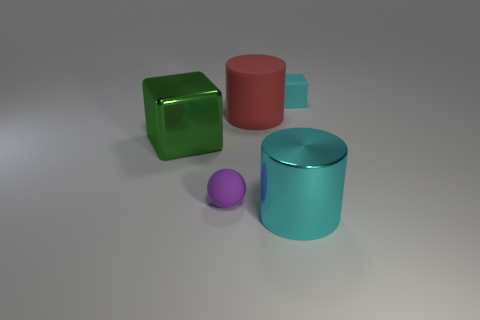What is the large red object made of?
Provide a succinct answer. Rubber. The small purple thing has what shape?
Provide a succinct answer. Sphere. What number of big matte cylinders have the same color as the small rubber sphere?
Offer a terse response. 0. What is the material of the cyan object that is left of the matte object on the right side of the cyan thing that is left of the small cyan object?
Make the answer very short. Metal. How many cyan objects are either small rubber cubes or large matte blocks?
Provide a succinct answer. 1. What is the size of the block that is in front of the thing that is on the right side of the cyan thing that is in front of the tiny cyan object?
Keep it short and to the point. Large. The cyan thing that is the same shape as the green object is what size?
Offer a terse response. Small. What number of tiny objects are brown metal spheres or metallic cylinders?
Give a very brief answer. 0. Do the large cylinder that is behind the purple rubber ball and the small object that is right of the cyan cylinder have the same material?
Offer a very short reply. Yes. There is a large cylinder that is behind the matte ball; what is it made of?
Provide a short and direct response. Rubber. 